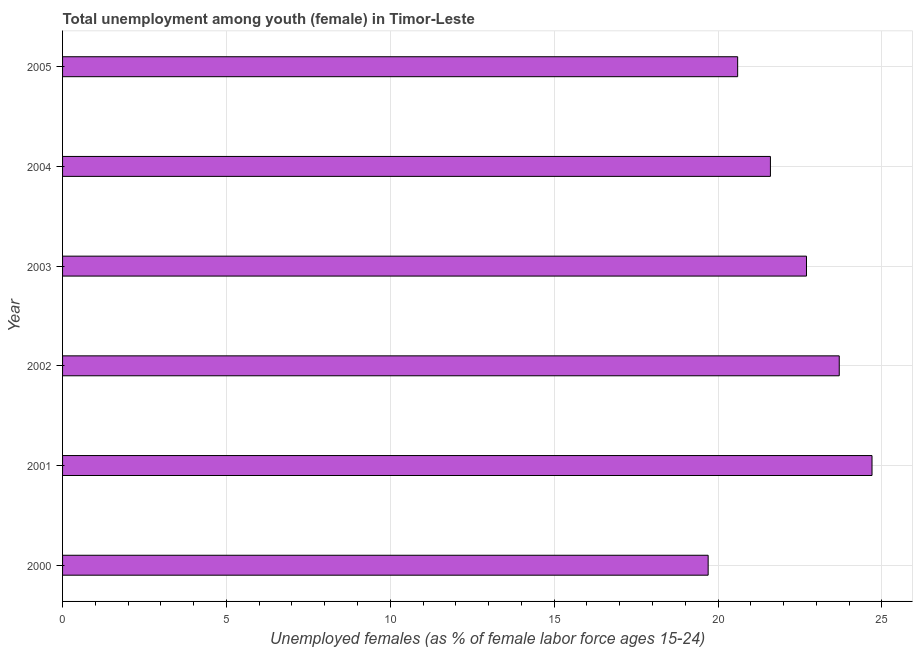Does the graph contain any zero values?
Give a very brief answer. No. Does the graph contain grids?
Provide a short and direct response. Yes. What is the title of the graph?
Provide a succinct answer. Total unemployment among youth (female) in Timor-Leste. What is the label or title of the X-axis?
Make the answer very short. Unemployed females (as % of female labor force ages 15-24). What is the label or title of the Y-axis?
Offer a very short reply. Year. What is the unemployed female youth population in 2005?
Provide a succinct answer. 20.6. Across all years, what is the maximum unemployed female youth population?
Ensure brevity in your answer.  24.7. Across all years, what is the minimum unemployed female youth population?
Give a very brief answer. 19.7. In which year was the unemployed female youth population maximum?
Keep it short and to the point. 2001. What is the sum of the unemployed female youth population?
Your answer should be compact. 133. What is the average unemployed female youth population per year?
Provide a succinct answer. 22.17. What is the median unemployed female youth population?
Offer a terse response. 22.15. Do a majority of the years between 2002 and 2005 (inclusive) have unemployed female youth population greater than 21 %?
Provide a succinct answer. Yes. What is the ratio of the unemployed female youth population in 2000 to that in 2002?
Offer a terse response. 0.83. Is the unemployed female youth population in 2001 less than that in 2005?
Your answer should be very brief. No. Is the difference between the unemployed female youth population in 2001 and 2004 greater than the difference between any two years?
Your answer should be compact. No. What is the difference between the highest and the second highest unemployed female youth population?
Ensure brevity in your answer.  1. Is the sum of the unemployed female youth population in 2001 and 2002 greater than the maximum unemployed female youth population across all years?
Make the answer very short. Yes. In how many years, is the unemployed female youth population greater than the average unemployed female youth population taken over all years?
Make the answer very short. 3. Are all the bars in the graph horizontal?
Give a very brief answer. Yes. How many years are there in the graph?
Provide a short and direct response. 6. What is the difference between two consecutive major ticks on the X-axis?
Keep it short and to the point. 5. Are the values on the major ticks of X-axis written in scientific E-notation?
Provide a succinct answer. No. What is the Unemployed females (as % of female labor force ages 15-24) of 2000?
Keep it short and to the point. 19.7. What is the Unemployed females (as % of female labor force ages 15-24) in 2001?
Provide a succinct answer. 24.7. What is the Unemployed females (as % of female labor force ages 15-24) of 2002?
Keep it short and to the point. 23.7. What is the Unemployed females (as % of female labor force ages 15-24) in 2003?
Provide a short and direct response. 22.7. What is the Unemployed females (as % of female labor force ages 15-24) of 2004?
Offer a very short reply. 21.6. What is the Unemployed females (as % of female labor force ages 15-24) of 2005?
Your answer should be very brief. 20.6. What is the difference between the Unemployed females (as % of female labor force ages 15-24) in 2000 and 2001?
Offer a very short reply. -5. What is the difference between the Unemployed females (as % of female labor force ages 15-24) in 2000 and 2003?
Your answer should be compact. -3. What is the difference between the Unemployed females (as % of female labor force ages 15-24) in 2000 and 2004?
Your answer should be compact. -1.9. What is the difference between the Unemployed females (as % of female labor force ages 15-24) in 2000 and 2005?
Keep it short and to the point. -0.9. What is the difference between the Unemployed females (as % of female labor force ages 15-24) in 2001 and 2004?
Ensure brevity in your answer.  3.1. What is the difference between the Unemployed females (as % of female labor force ages 15-24) in 2001 and 2005?
Your answer should be compact. 4.1. What is the difference between the Unemployed females (as % of female labor force ages 15-24) in 2002 and 2005?
Your answer should be compact. 3.1. What is the difference between the Unemployed females (as % of female labor force ages 15-24) in 2003 and 2004?
Ensure brevity in your answer.  1.1. What is the ratio of the Unemployed females (as % of female labor force ages 15-24) in 2000 to that in 2001?
Your response must be concise. 0.8. What is the ratio of the Unemployed females (as % of female labor force ages 15-24) in 2000 to that in 2002?
Offer a very short reply. 0.83. What is the ratio of the Unemployed females (as % of female labor force ages 15-24) in 2000 to that in 2003?
Provide a short and direct response. 0.87. What is the ratio of the Unemployed females (as % of female labor force ages 15-24) in 2000 to that in 2004?
Make the answer very short. 0.91. What is the ratio of the Unemployed females (as % of female labor force ages 15-24) in 2000 to that in 2005?
Offer a very short reply. 0.96. What is the ratio of the Unemployed females (as % of female labor force ages 15-24) in 2001 to that in 2002?
Your answer should be compact. 1.04. What is the ratio of the Unemployed females (as % of female labor force ages 15-24) in 2001 to that in 2003?
Give a very brief answer. 1.09. What is the ratio of the Unemployed females (as % of female labor force ages 15-24) in 2001 to that in 2004?
Offer a very short reply. 1.14. What is the ratio of the Unemployed females (as % of female labor force ages 15-24) in 2001 to that in 2005?
Your answer should be compact. 1.2. What is the ratio of the Unemployed females (as % of female labor force ages 15-24) in 2002 to that in 2003?
Keep it short and to the point. 1.04. What is the ratio of the Unemployed females (as % of female labor force ages 15-24) in 2002 to that in 2004?
Your answer should be very brief. 1.1. What is the ratio of the Unemployed females (as % of female labor force ages 15-24) in 2002 to that in 2005?
Give a very brief answer. 1.15. What is the ratio of the Unemployed females (as % of female labor force ages 15-24) in 2003 to that in 2004?
Ensure brevity in your answer.  1.05. What is the ratio of the Unemployed females (as % of female labor force ages 15-24) in 2003 to that in 2005?
Offer a very short reply. 1.1. What is the ratio of the Unemployed females (as % of female labor force ages 15-24) in 2004 to that in 2005?
Your answer should be compact. 1.05. 